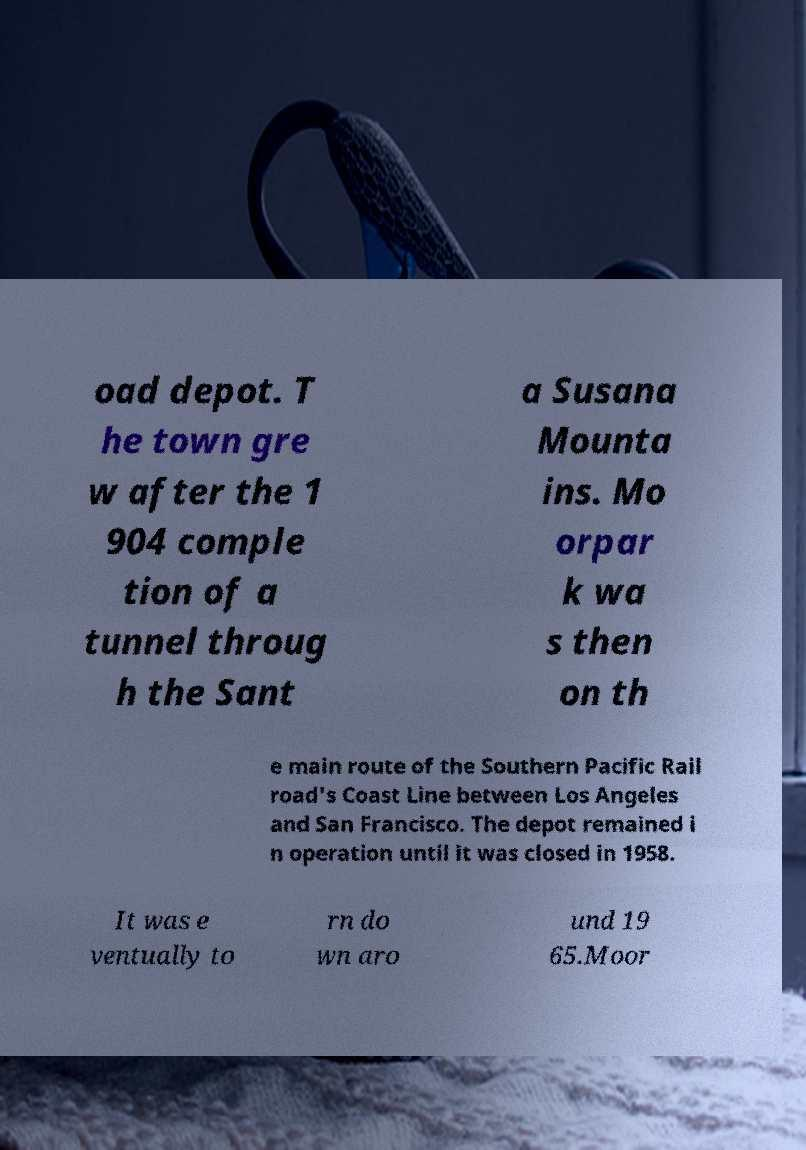For documentation purposes, I need the text within this image transcribed. Could you provide that? oad depot. T he town gre w after the 1 904 comple tion of a tunnel throug h the Sant a Susana Mounta ins. Mo orpar k wa s then on th e main route of the Southern Pacific Rail road's Coast Line between Los Angeles and San Francisco. The depot remained i n operation until it was closed in 1958. It was e ventually to rn do wn aro und 19 65.Moor 